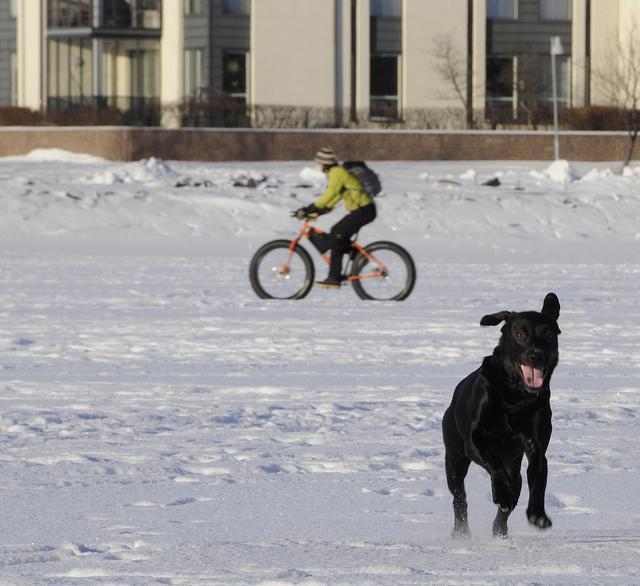How many people are riding bikes here?
Give a very brief answer. 1. 